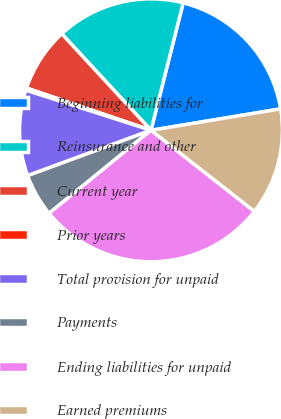<chart> <loc_0><loc_0><loc_500><loc_500><pie_chart><fcel>Beginning liabilities for<fcel>Reinsurance and other<fcel>Current year<fcel>Prior years<fcel>Total provision for unpaid<fcel>Payments<fcel>Ending liabilities for unpaid<fcel>Earned premiums<nl><fcel>18.46%<fcel>15.82%<fcel>7.91%<fcel>0.27%<fcel>10.55%<fcel>5.27%<fcel>28.54%<fcel>13.19%<nl></chart> 